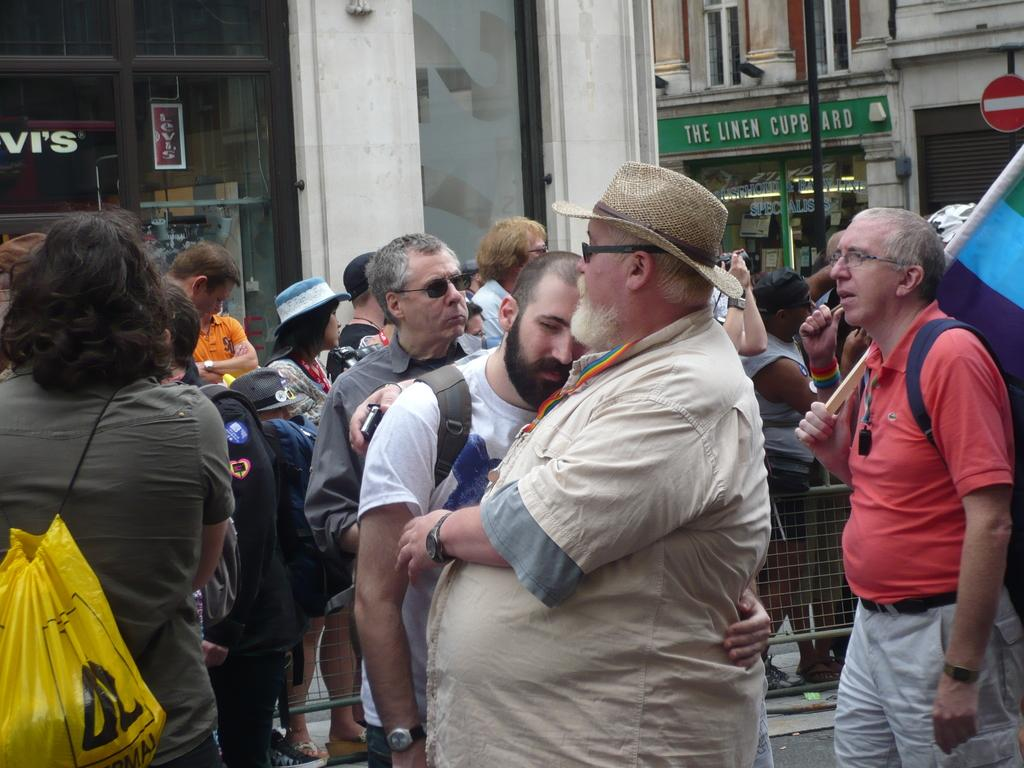What is happening with the group of people in the image? There is a group of people standing on the street in the image. Can you describe any specific actions or objects held by someone in the group? Yes, there is a person holding a flag in the image. What can be seen in the background of the image? There are buildings with name boards and a pole visible in the background. What type of art can be seen on the hot surface in the image? There is no art or hot surface present in the image. 